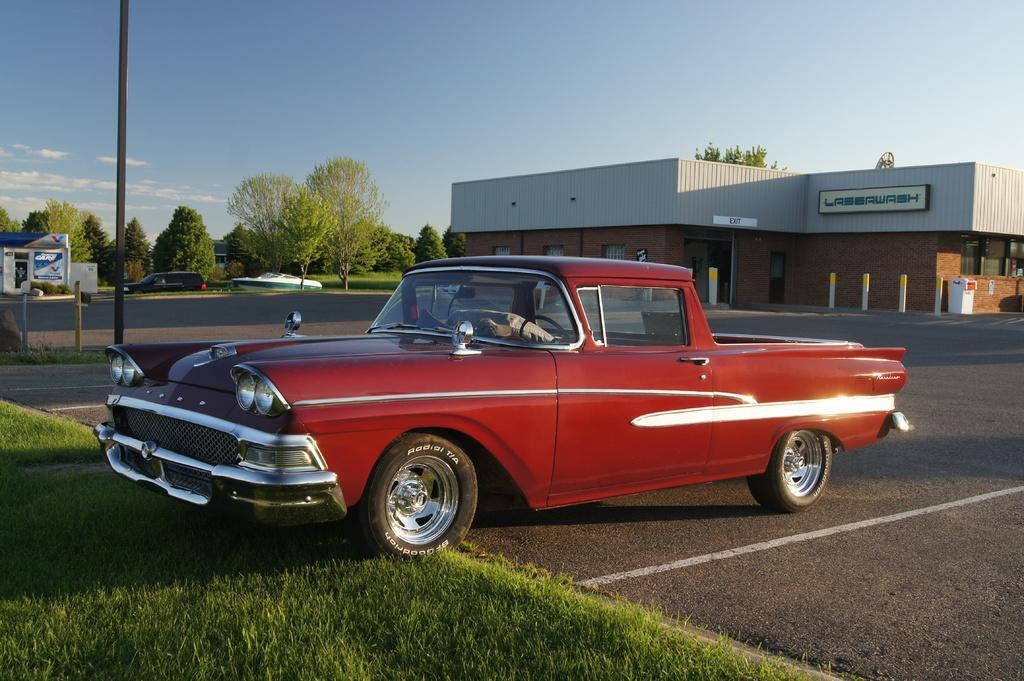How would you summarize this image in a sentence or two? There is a car. On the ground there is grass. Also there is a pole near to the car. In the back there are many trees and building with windows. On the building there is a name. Near to the building there are poles. In the back there is a vehicle and a boat. In the background there is sky with clouds. 